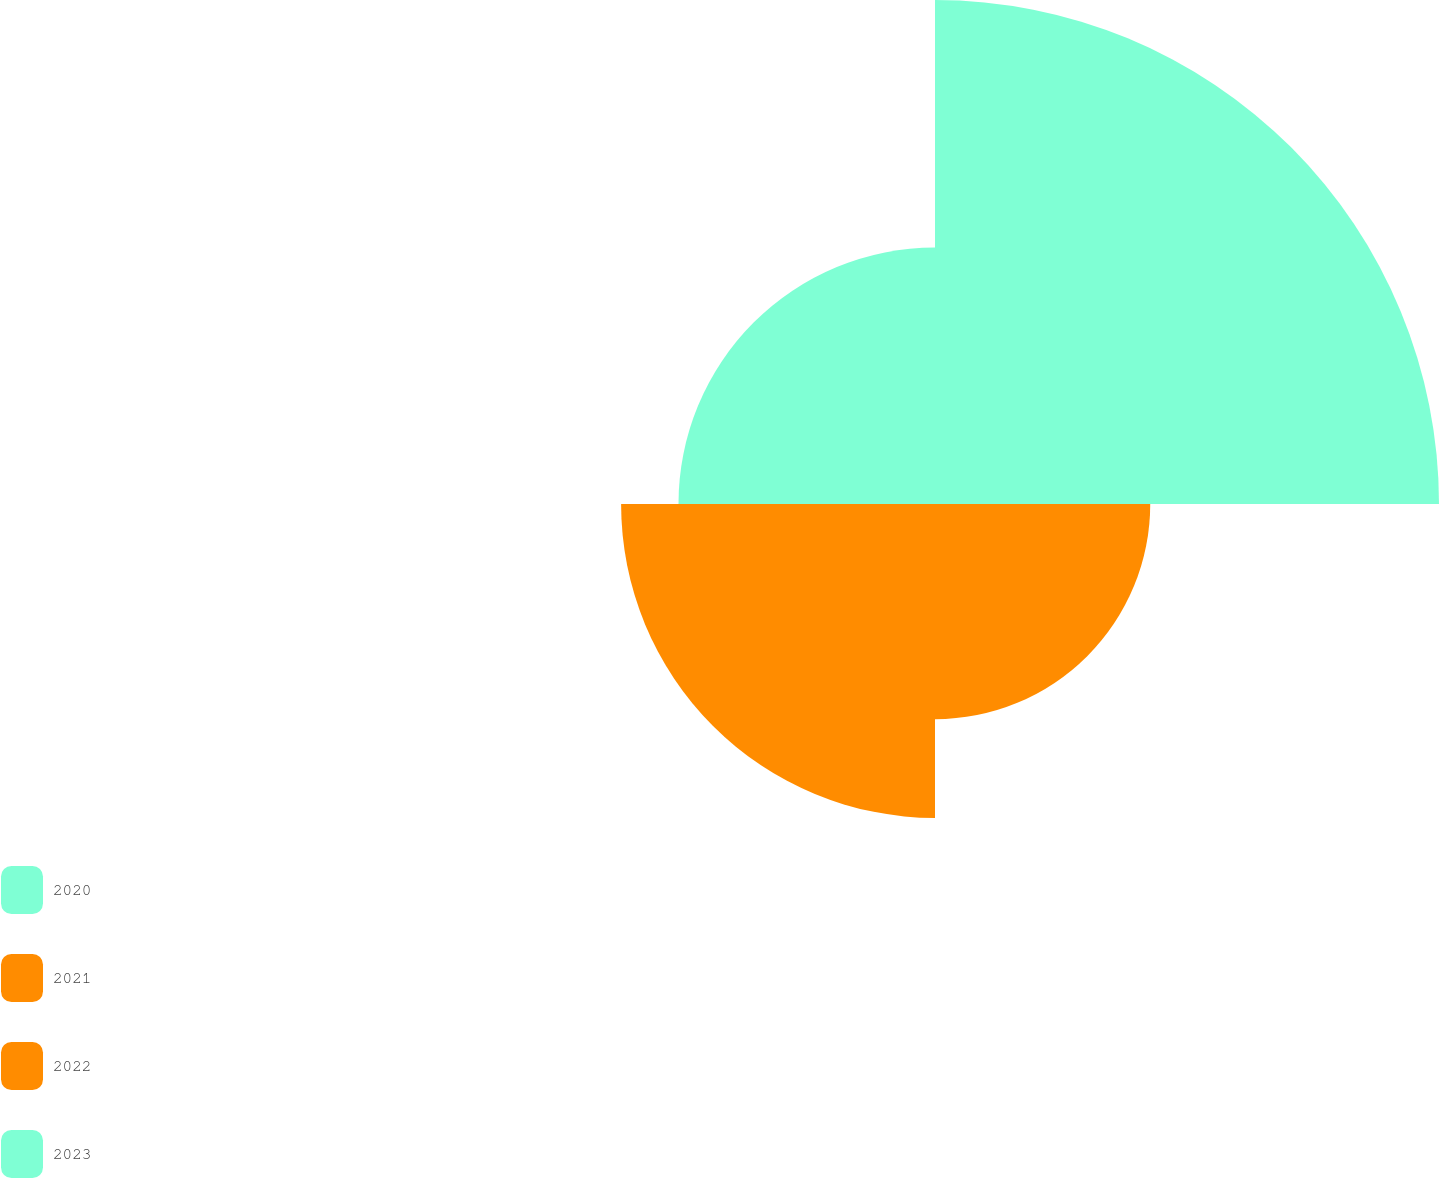<chart> <loc_0><loc_0><loc_500><loc_500><pie_chart><fcel>2020<fcel>2021<fcel>2022<fcel>2023<nl><fcel>39.08%<fcel>16.69%<fcel>24.34%<fcel>19.89%<nl></chart> 